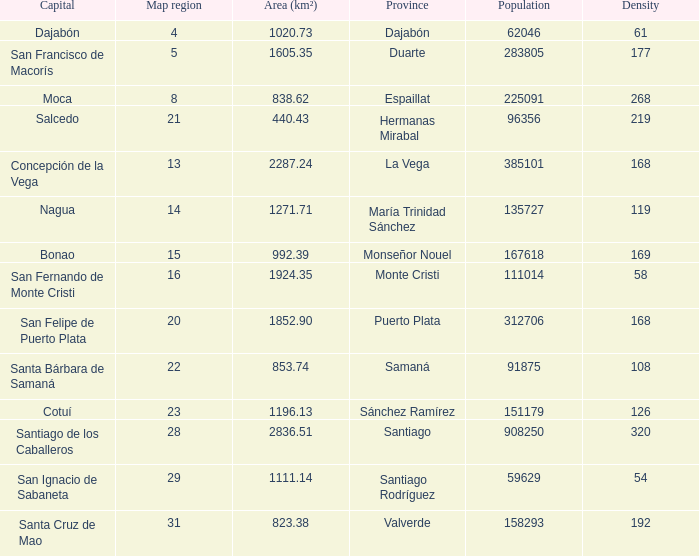When province is monseñor nouel, what is the area (km²)? 992.39. 